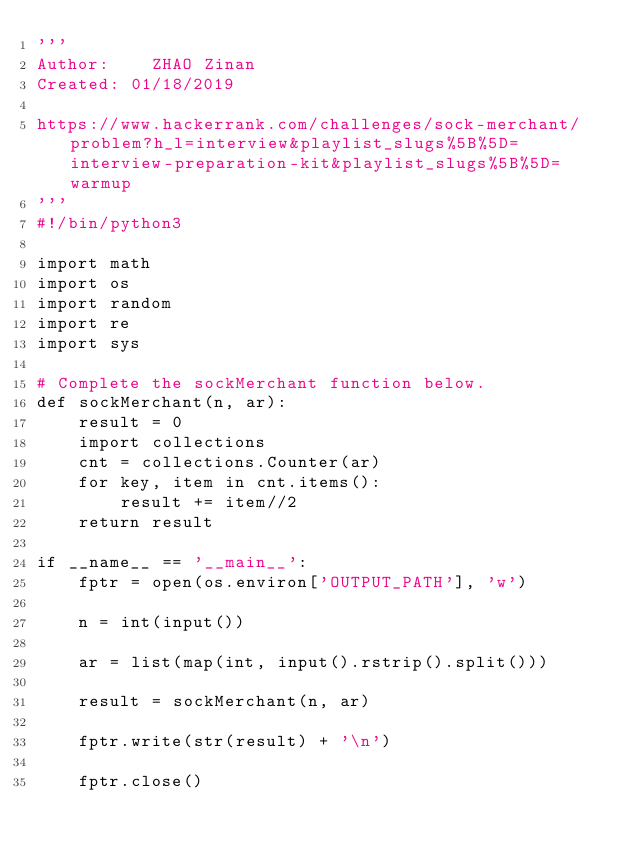Convert code to text. <code><loc_0><loc_0><loc_500><loc_500><_Python_>'''
Author:    ZHAO Zinan
Created: 01/18/2019

https://www.hackerrank.com/challenges/sock-merchant/problem?h_l=interview&playlist_slugs%5B%5D=interview-preparation-kit&playlist_slugs%5B%5D=warmup
'''
#!/bin/python3

import math
import os
import random
import re
import sys

# Complete the sockMerchant function below.
def sockMerchant(n, ar):
    result = 0
    import collections
    cnt = collections.Counter(ar)
    for key, item in cnt.items():
        result += item//2
    return result

if __name__ == '__main__':
    fptr = open(os.environ['OUTPUT_PATH'], 'w')

    n = int(input())

    ar = list(map(int, input().rstrip().split()))

    result = sockMerchant(n, ar)

    fptr.write(str(result) + '\n')

    fptr.close()
</code> 